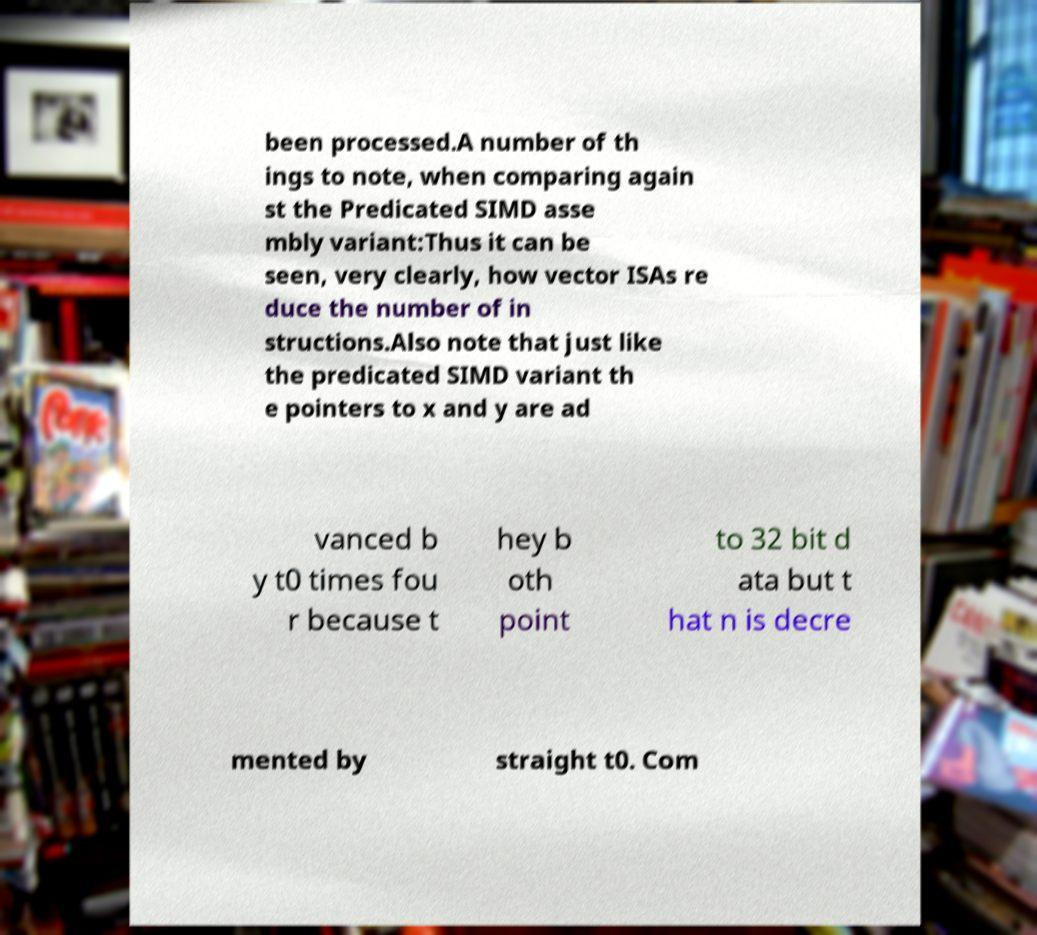Please identify and transcribe the text found in this image. been processed.A number of th ings to note, when comparing again st the Predicated SIMD asse mbly variant:Thus it can be seen, very clearly, how vector ISAs re duce the number of in structions.Also note that just like the predicated SIMD variant th e pointers to x and y are ad vanced b y t0 times fou r because t hey b oth point to 32 bit d ata but t hat n is decre mented by straight t0. Com 